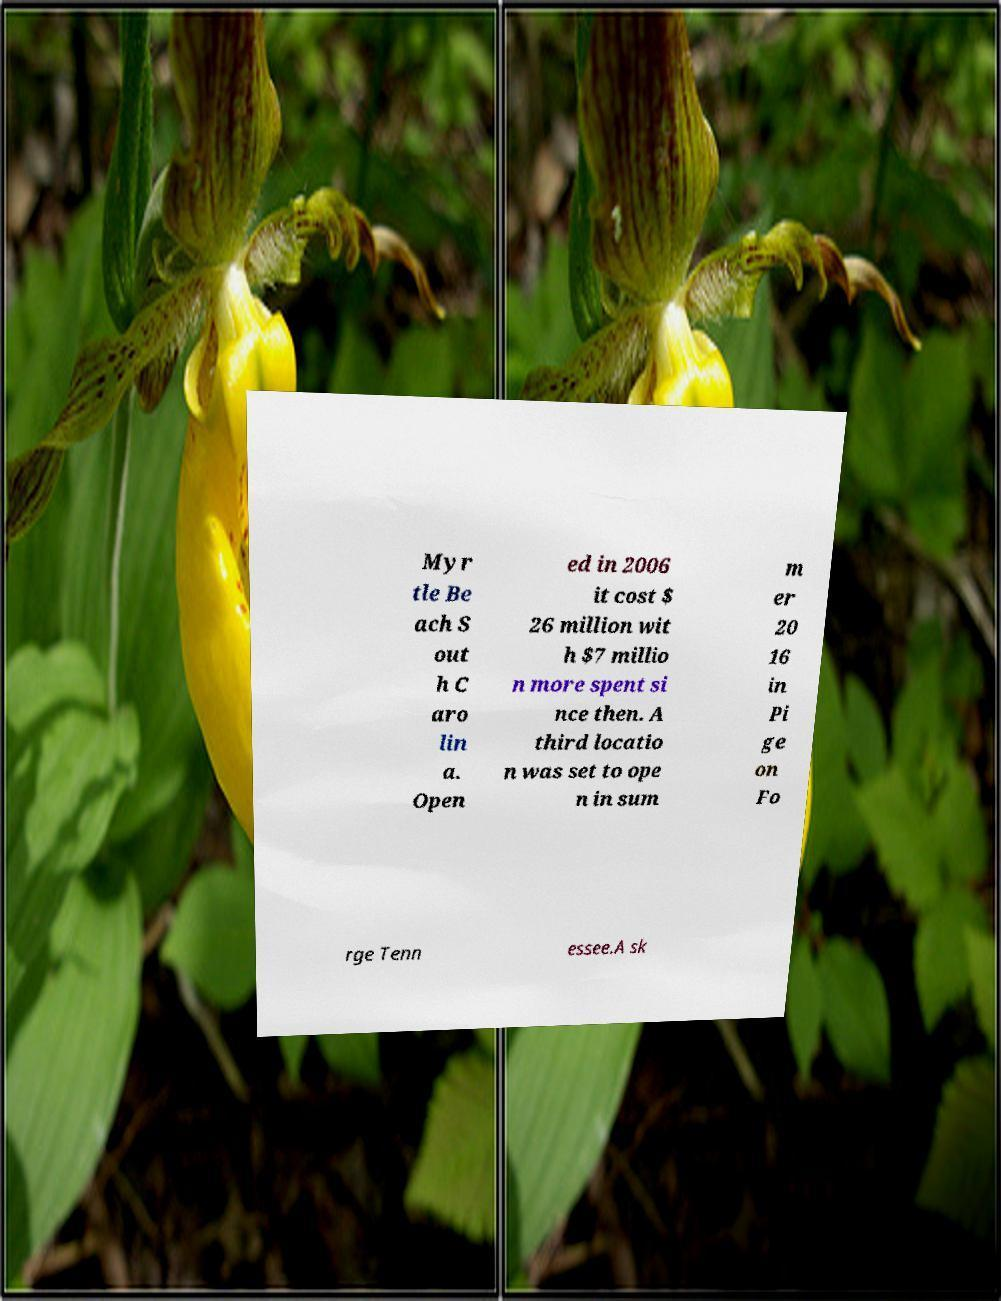I need the written content from this picture converted into text. Can you do that? Myr tle Be ach S out h C aro lin a. Open ed in 2006 it cost $ 26 million wit h $7 millio n more spent si nce then. A third locatio n was set to ope n in sum m er 20 16 in Pi ge on Fo rge Tenn essee.A sk 